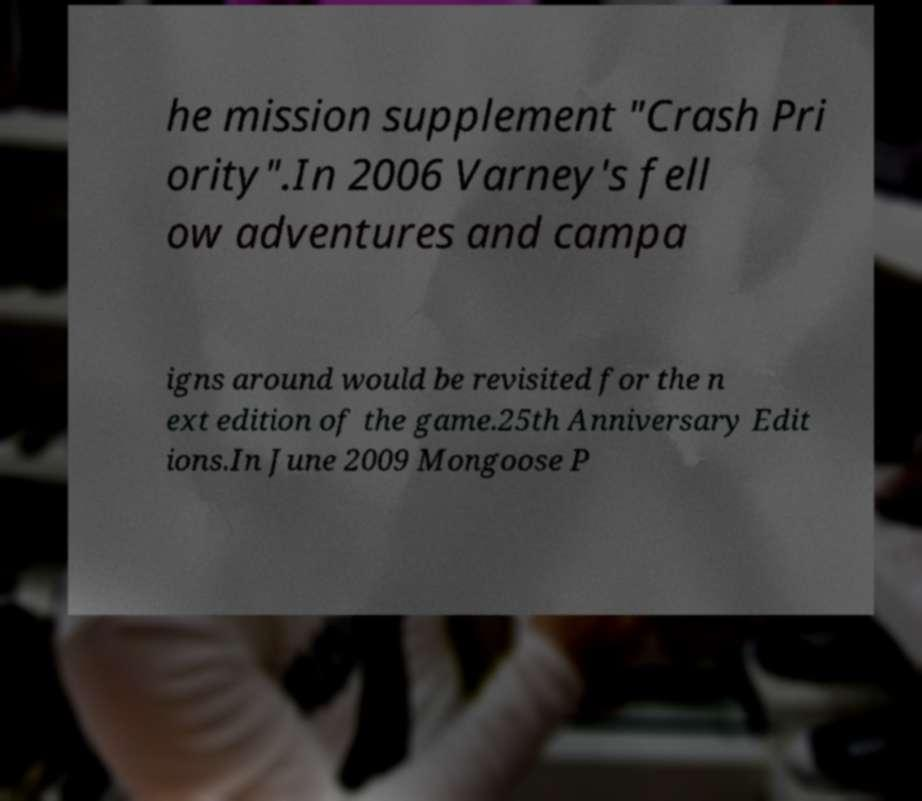Please identify and transcribe the text found in this image. he mission supplement "Crash Pri ority".In 2006 Varney's fell ow adventures and campa igns around would be revisited for the n ext edition of the game.25th Anniversary Edit ions.In June 2009 Mongoose P 